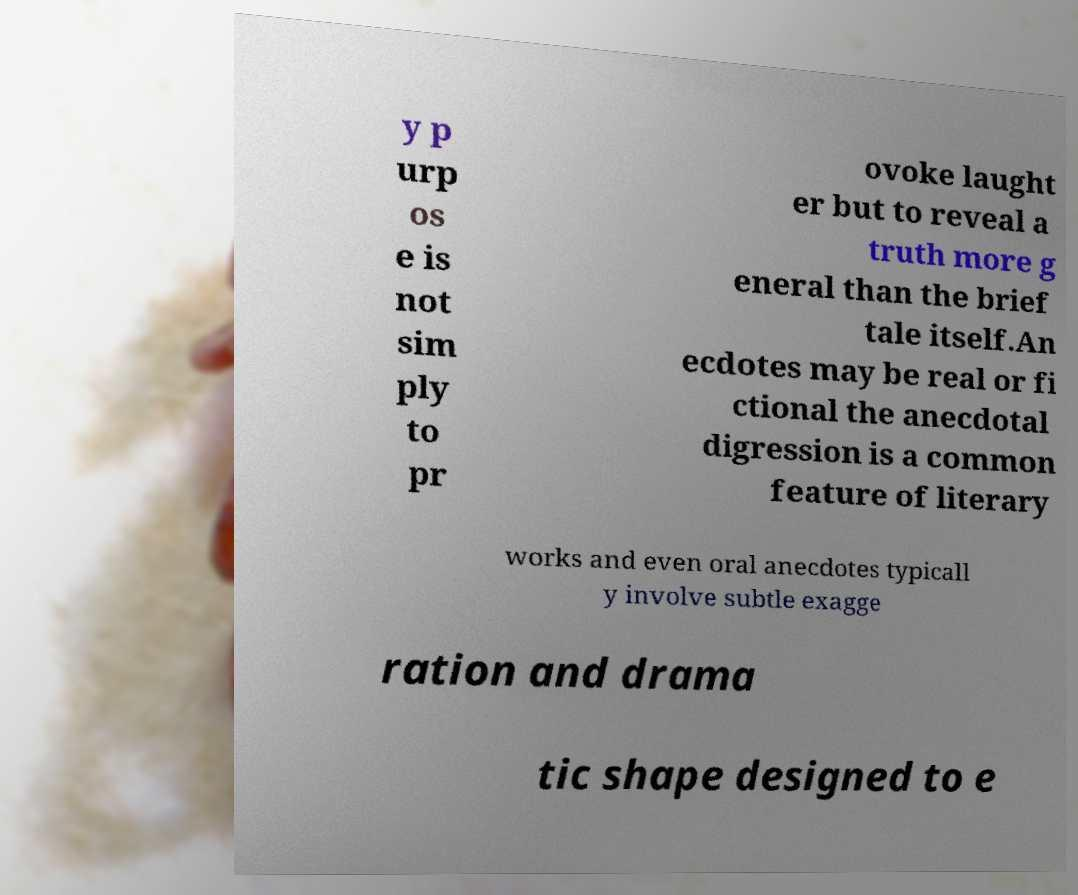Can you read and provide the text displayed in the image?This photo seems to have some interesting text. Can you extract and type it out for me? y p urp os e is not sim ply to pr ovoke laught er but to reveal a truth more g eneral than the brief tale itself.An ecdotes may be real or fi ctional the anecdotal digression is a common feature of literary works and even oral anecdotes typicall y involve subtle exagge ration and drama tic shape designed to e 